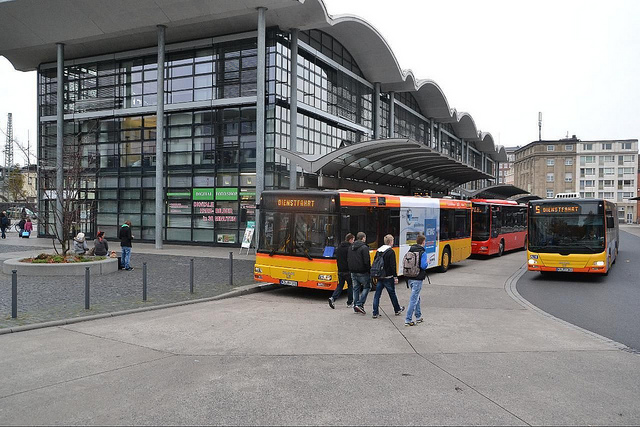How many buses are there? 3 